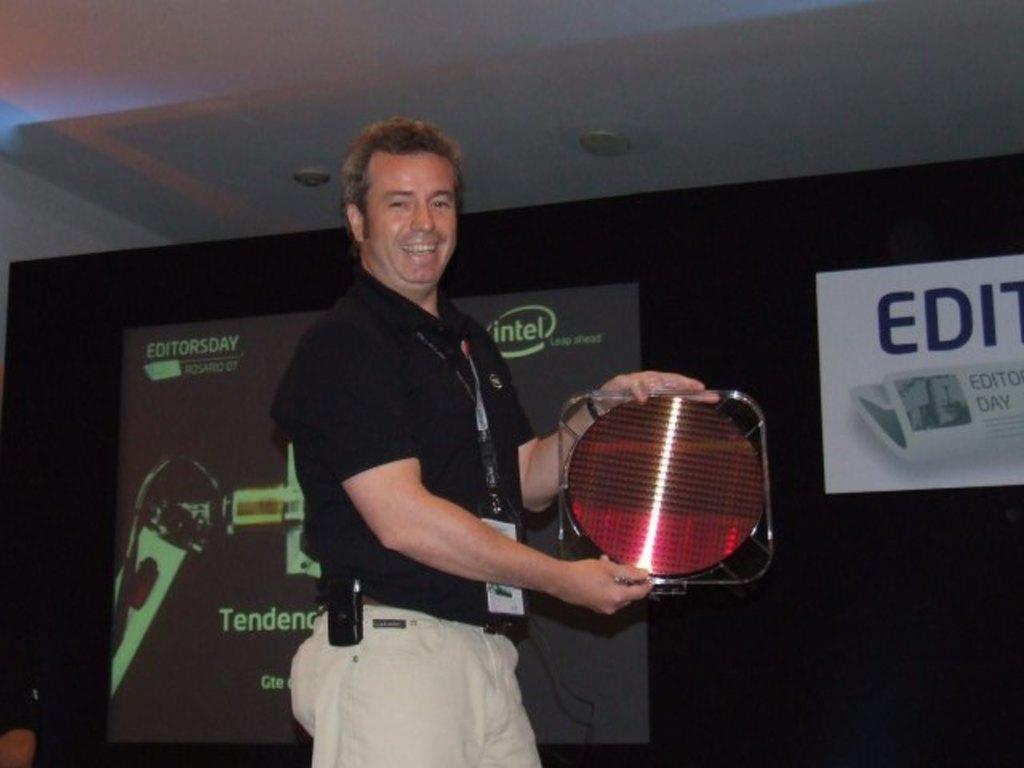In one or two sentences, can you explain what this image depicts? In the middle of the image, there is a person in a black color T-shirt, holding an object which is in circular shape, smiling and standing. In the background, there is a screen, there is a poster, there is a white color roof and there is a black color sheet. 